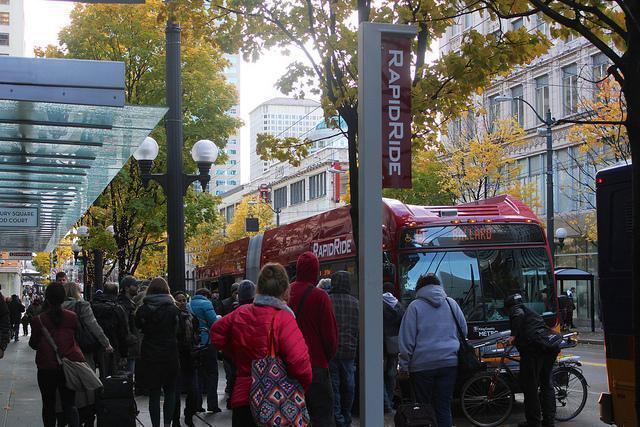What area is shown here?
Select the accurate answer and provide justification: `Answer: choice
Rationale: srationale.`
Options: Bus stop, cake walk, taxi stand, bike pull. Answer: bus stop.
Rationale: People stand at a covered area near the curb of a busy street as a bus approaches. Who are the people gathering there?
Select the accurate answer and provide explanation: 'Answer: answer
Rationale: rationale.'
Options: Friends, coworkers, tourists, students. Answer: tourists.
Rationale: Any of the answers could be possible, but the people appear to be lining up to board a bus commonly used by answer a. 